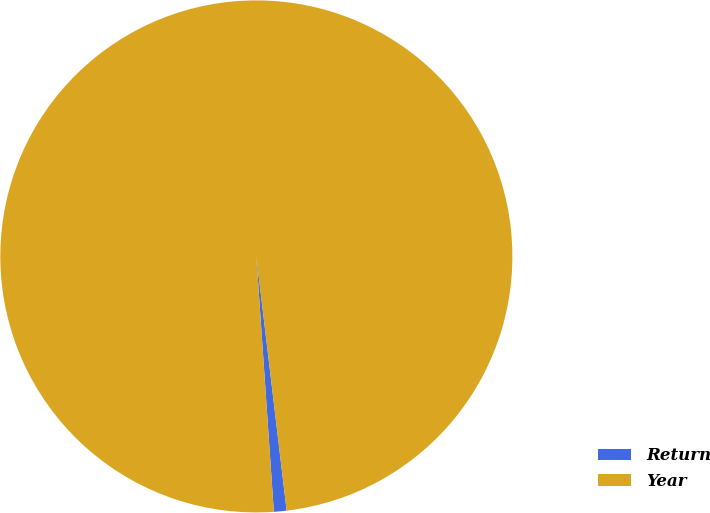<chart> <loc_0><loc_0><loc_500><loc_500><pie_chart><fcel>Return<fcel>Year<nl><fcel>0.8%<fcel>99.2%<nl></chart> 